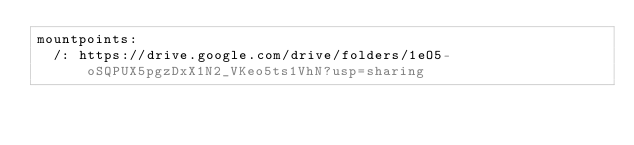Convert code to text. <code><loc_0><loc_0><loc_500><loc_500><_YAML_>mountpoints:
  /: https://drive.google.com/drive/folders/1eO5-oSQPUX5pgzDxX1N2_VKeo5ts1VhN?usp=sharing
</code> 